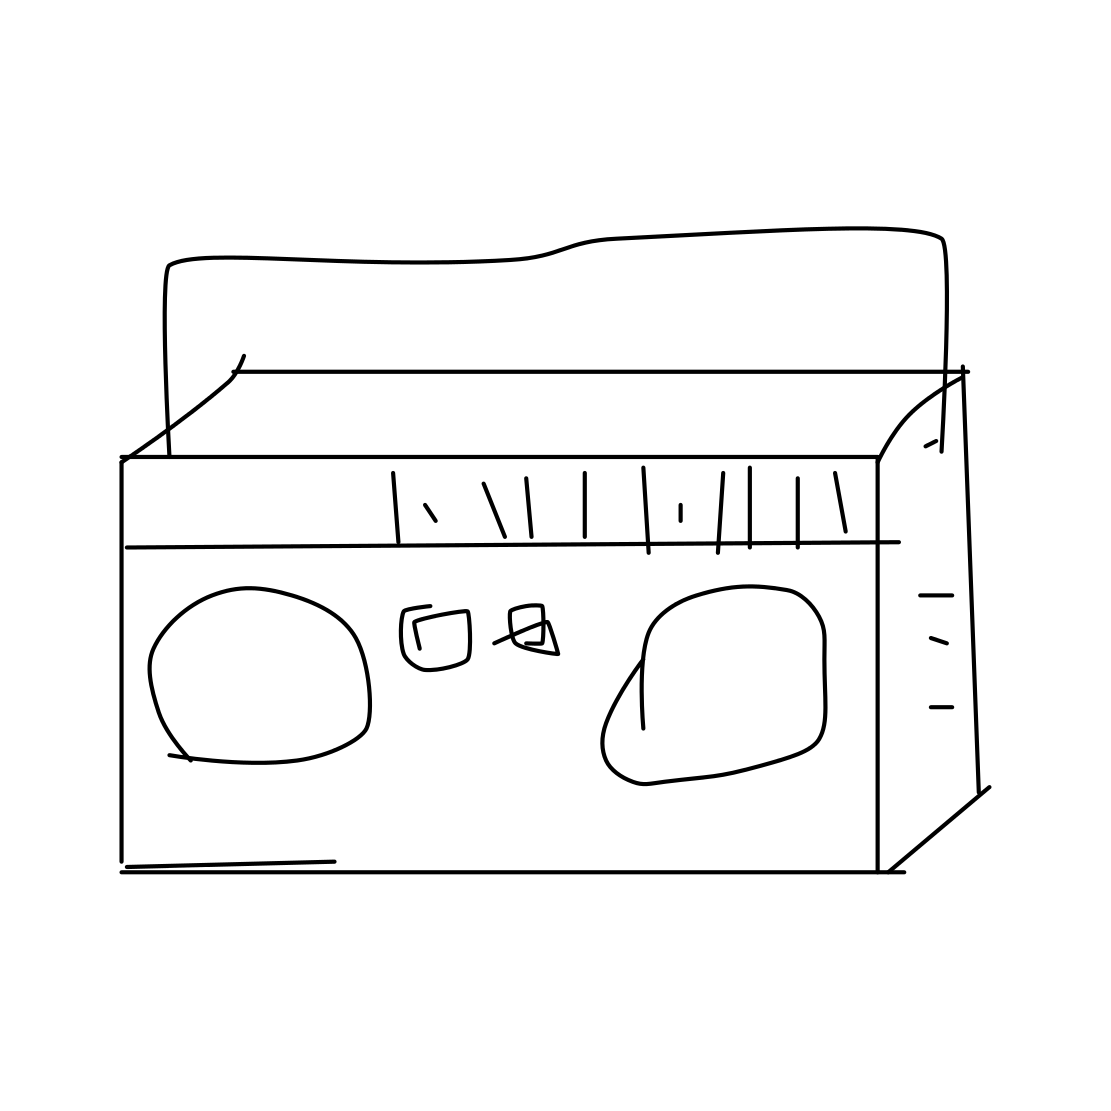Can you explain how this object works? Certainly! The cassette tape holds magnetic tape that stores audio information in an analog format. As the tape passes between two reels inside the cassette, a tape head reads or writes the audio signals. It requires a cassette player or recorder to function, where the tape heads interact with the magnetic tape to play back or record sounds. 